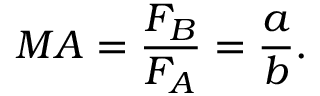<formula> <loc_0><loc_0><loc_500><loc_500>M A = { \frac { F _ { B } } { F _ { A } } } = { \frac { a } { b } } .</formula> 